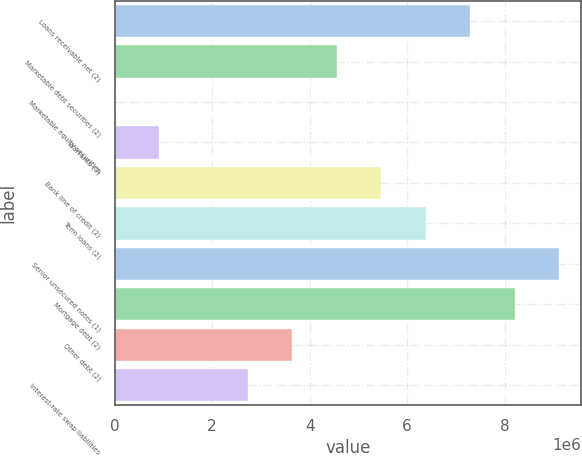Convert chart to OTSL. <chart><loc_0><loc_0><loc_500><loc_500><bar_chart><fcel>Loans receivable net (2)<fcel>Marketable debt securities (2)<fcel>Marketable equity securities<fcel>Warrants (3)<fcel>Bank line of credit (2)<fcel>Term loans (2)<fcel>Senior unsecured notes (1)<fcel>Mortgage debt (2)<fcel>Other debt (2)<fcel>Interest-rate swap liabilities<nl><fcel>7.29609e+06<fcel>4.56007e+06<fcel>39<fcel>912046<fcel>5.47208e+06<fcel>6.38409e+06<fcel>9.12011e+06<fcel>8.2081e+06<fcel>3.64807e+06<fcel>2.73606e+06<nl></chart> 